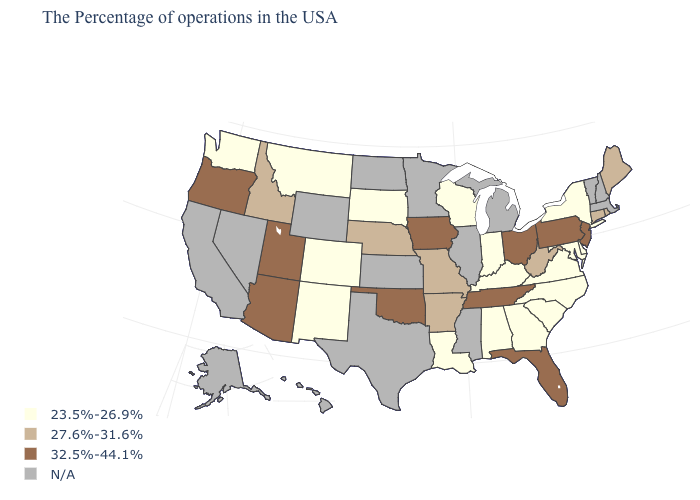Name the states that have a value in the range N/A?
Answer briefly. Massachusetts, New Hampshire, Vermont, Michigan, Illinois, Mississippi, Minnesota, Kansas, Texas, North Dakota, Wyoming, Nevada, California, Alaska, Hawaii. What is the value of Wisconsin?
Quick response, please. 23.5%-26.9%. Name the states that have a value in the range 27.6%-31.6%?
Write a very short answer. Maine, Rhode Island, Connecticut, West Virginia, Missouri, Arkansas, Nebraska, Idaho. Does New Jersey have the highest value in the USA?
Keep it brief. Yes. Which states have the lowest value in the West?
Answer briefly. Colorado, New Mexico, Montana, Washington. Does New York have the lowest value in the Northeast?
Write a very short answer. Yes. Does New York have the highest value in the USA?
Keep it brief. No. What is the value of California?
Write a very short answer. N/A. Among the states that border Delaware , which have the lowest value?
Short answer required. Maryland. Does the first symbol in the legend represent the smallest category?
Keep it brief. Yes. What is the highest value in the USA?
Short answer required. 32.5%-44.1%. What is the value of North Carolina?
Answer briefly. 23.5%-26.9%. What is the lowest value in the USA?
Keep it brief. 23.5%-26.9%. Among the states that border Wyoming , which have the highest value?
Quick response, please. Utah. 